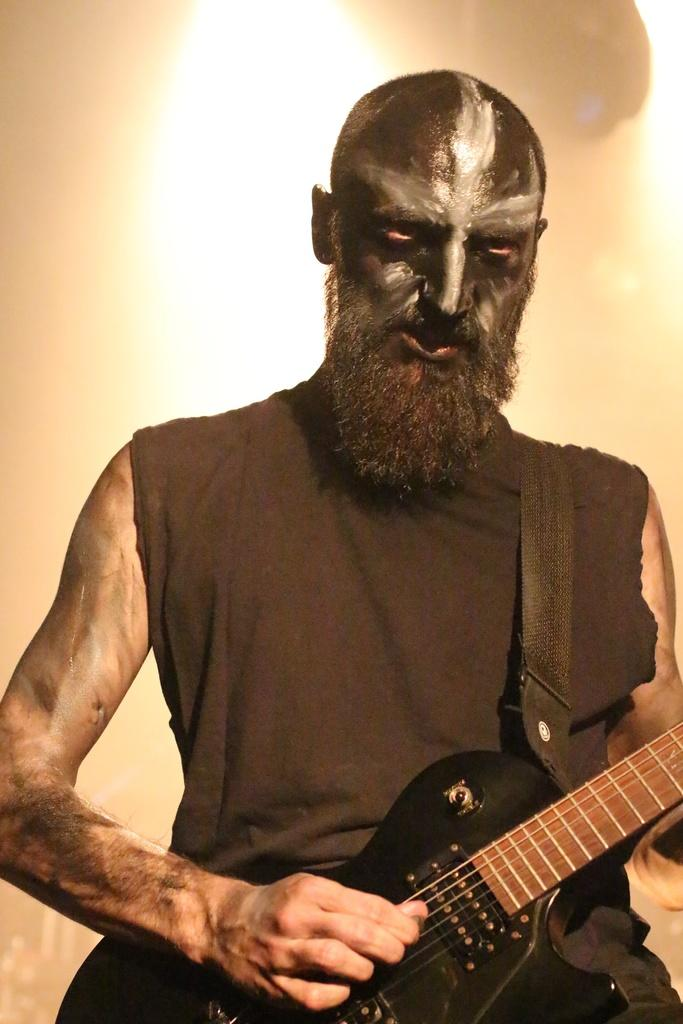What is the main subject of the image? There is a man in the image. What is the man doing in the image? The man is standing in the image. What object is the man holding in his hand? The man is holding a guitar in his hand. What type of glue can be seen on the man's ear in the image? There is no glue or ear visible in the image; the man is holding a guitar. 